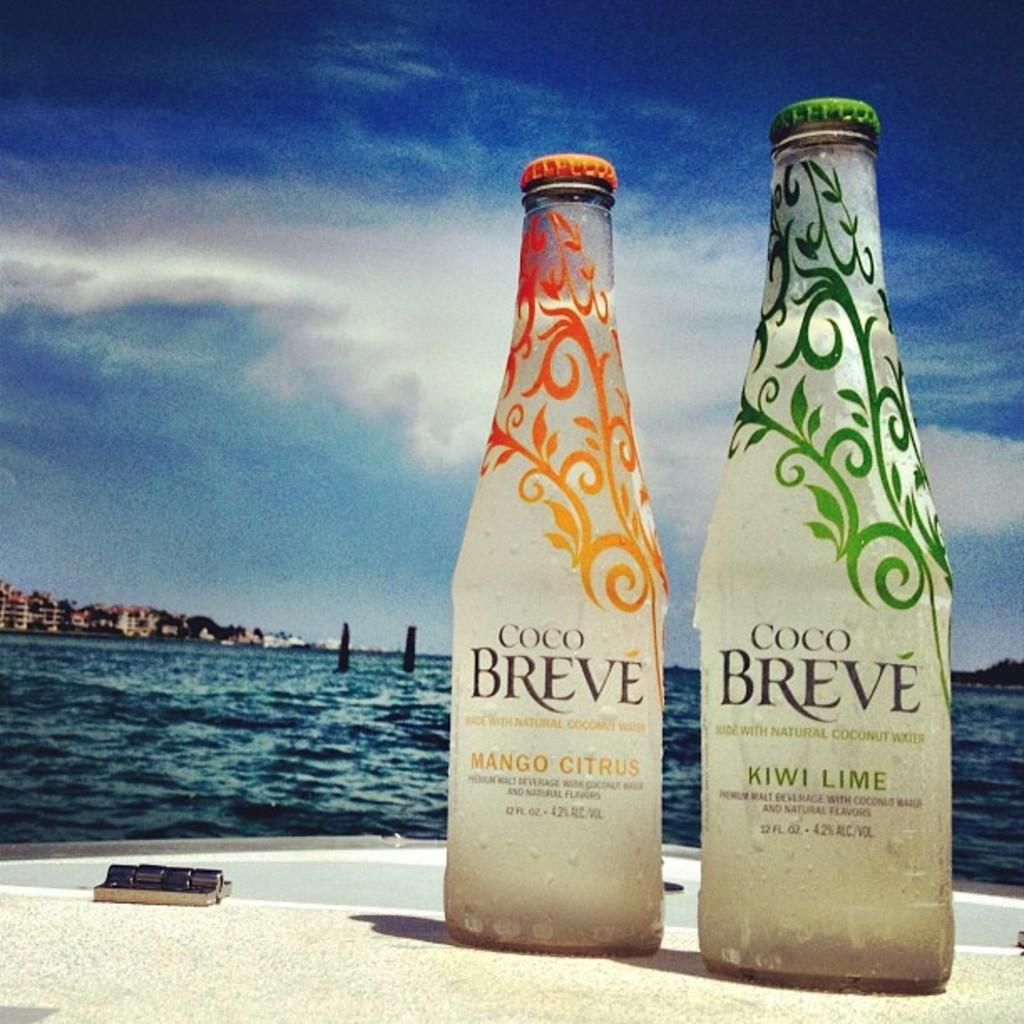<image>
Create a compact narrative representing the image presented. Two bottles of Coco Breve sit on a shelf in front of water. 